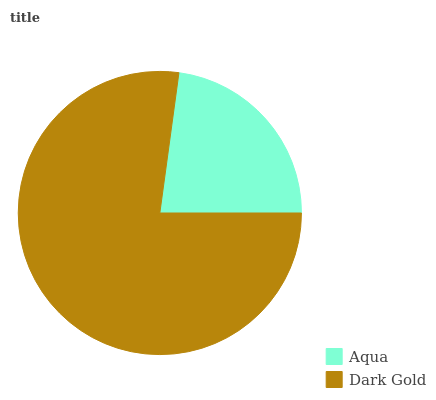Is Aqua the minimum?
Answer yes or no. Yes. Is Dark Gold the maximum?
Answer yes or no. Yes. Is Dark Gold the minimum?
Answer yes or no. No. Is Dark Gold greater than Aqua?
Answer yes or no. Yes. Is Aqua less than Dark Gold?
Answer yes or no. Yes. Is Aqua greater than Dark Gold?
Answer yes or no. No. Is Dark Gold less than Aqua?
Answer yes or no. No. Is Dark Gold the high median?
Answer yes or no. Yes. Is Aqua the low median?
Answer yes or no. Yes. Is Aqua the high median?
Answer yes or no. No. Is Dark Gold the low median?
Answer yes or no. No. 